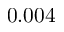<formula> <loc_0><loc_0><loc_500><loc_500>0 . 0 0 4</formula> 